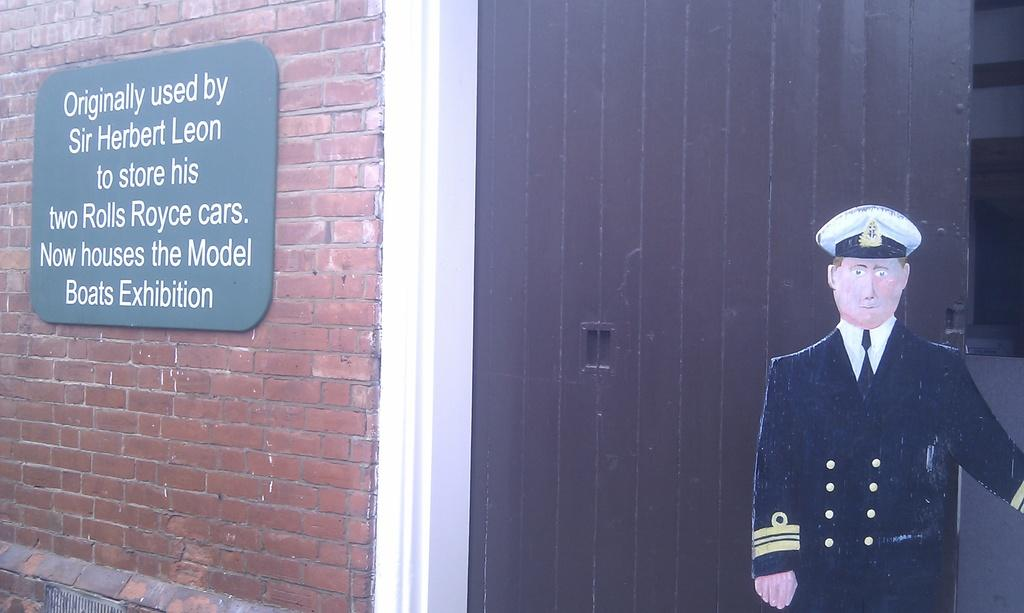What is attached to the wall in the image? There is a board attached to the wall in the image. What material is the board made of? The board is made of wood. What other wooden object can be seen in the image? There is a wooden door in the image. What is depicted on the board? There is a cutout of a man in uniform on the board. What is the texture of the wall in the image? The wall has a brick texture. How does the man in uniform on the board experience temper in the image? The man in uniform on the board is a cutout and does not experience emotions like temper. 